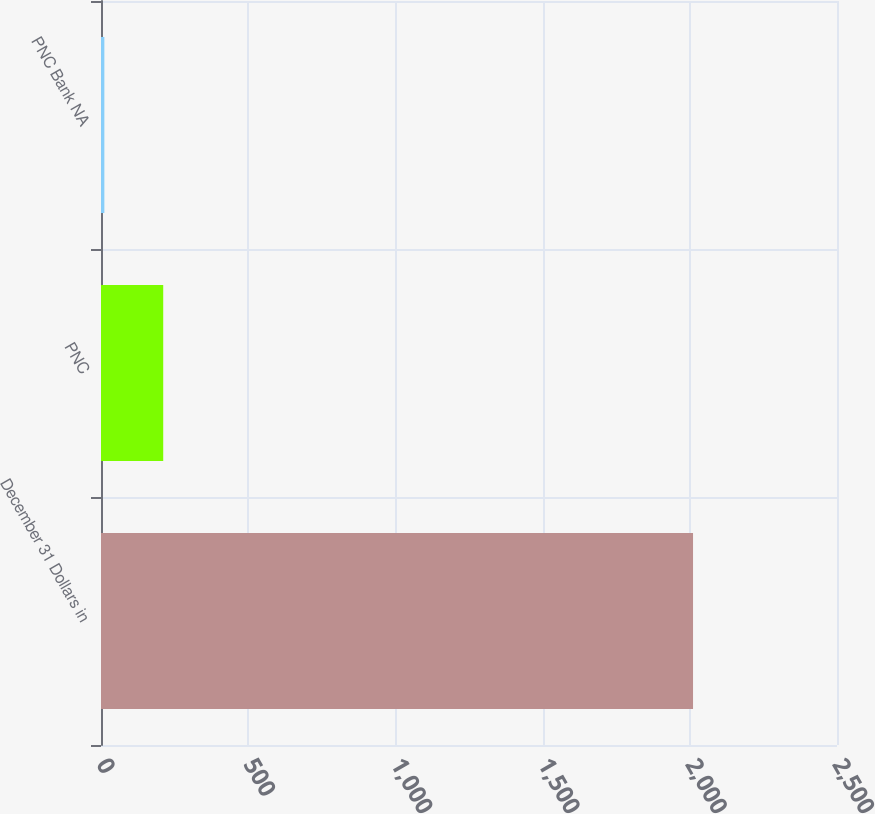<chart> <loc_0><loc_0><loc_500><loc_500><bar_chart><fcel>December 31 Dollars in<fcel>PNC<fcel>PNC Bank NA<nl><fcel>2011<fcel>211.36<fcel>11.4<nl></chart> 